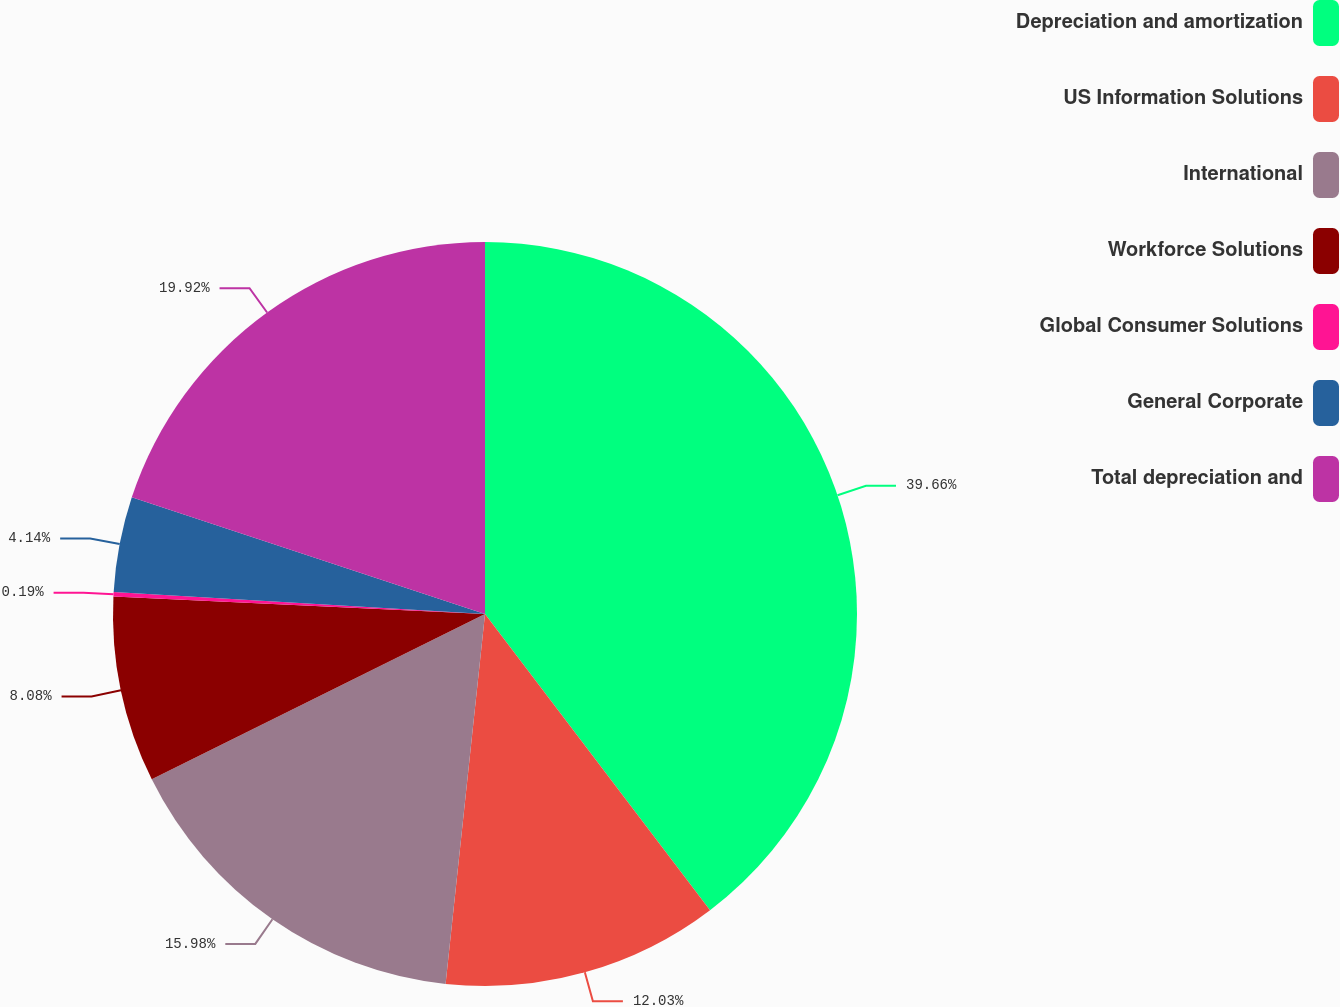<chart> <loc_0><loc_0><loc_500><loc_500><pie_chart><fcel>Depreciation and amortization<fcel>US Information Solutions<fcel>International<fcel>Workforce Solutions<fcel>Global Consumer Solutions<fcel>General Corporate<fcel>Total depreciation and<nl><fcel>39.66%<fcel>12.03%<fcel>15.98%<fcel>8.08%<fcel>0.19%<fcel>4.14%<fcel>19.92%<nl></chart> 